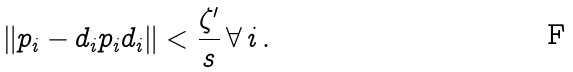<formula> <loc_0><loc_0><loc_500><loc_500>\| p _ { i } - d _ { i } p _ { i } d _ { i } \| < \frac { \zeta ^ { \prime } } { s } \, \forall \, i \, .</formula> 